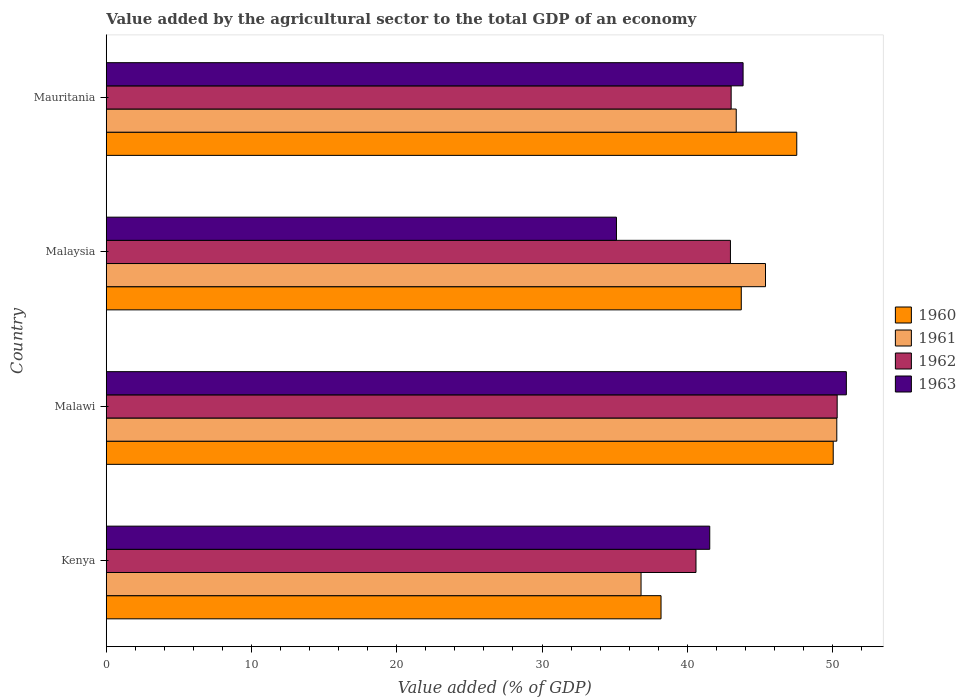How many different coloured bars are there?
Provide a succinct answer. 4. Are the number of bars per tick equal to the number of legend labels?
Your response must be concise. Yes. How many bars are there on the 1st tick from the bottom?
Offer a very short reply. 4. What is the label of the 2nd group of bars from the top?
Provide a succinct answer. Malaysia. What is the value added by the agricultural sector to the total GDP in 1960 in Mauritania?
Provide a succinct answer. 47.53. Across all countries, what is the maximum value added by the agricultural sector to the total GDP in 1963?
Ensure brevity in your answer.  50.95. Across all countries, what is the minimum value added by the agricultural sector to the total GDP in 1962?
Provide a short and direct response. 40.6. In which country was the value added by the agricultural sector to the total GDP in 1961 maximum?
Provide a succinct answer. Malawi. In which country was the value added by the agricultural sector to the total GDP in 1961 minimum?
Your answer should be very brief. Kenya. What is the total value added by the agricultural sector to the total GDP in 1961 in the graph?
Provide a short and direct response. 175.86. What is the difference between the value added by the agricultural sector to the total GDP in 1960 in Kenya and that in Malawi?
Ensure brevity in your answer.  -11.85. What is the difference between the value added by the agricultural sector to the total GDP in 1961 in Kenya and the value added by the agricultural sector to the total GDP in 1960 in Malawi?
Offer a terse response. -13.23. What is the average value added by the agricultural sector to the total GDP in 1962 per country?
Provide a short and direct response. 44.23. What is the difference between the value added by the agricultural sector to the total GDP in 1960 and value added by the agricultural sector to the total GDP in 1963 in Malawi?
Ensure brevity in your answer.  -0.9. What is the ratio of the value added by the agricultural sector to the total GDP in 1960 in Kenya to that in Mauritania?
Your answer should be compact. 0.8. What is the difference between the highest and the second highest value added by the agricultural sector to the total GDP in 1961?
Ensure brevity in your answer.  4.91. What is the difference between the highest and the lowest value added by the agricultural sector to the total GDP in 1960?
Provide a succinct answer. 11.85. In how many countries, is the value added by the agricultural sector to the total GDP in 1961 greater than the average value added by the agricultural sector to the total GDP in 1961 taken over all countries?
Offer a very short reply. 2. Is the sum of the value added by the agricultural sector to the total GDP in 1963 in Kenya and Malawi greater than the maximum value added by the agricultural sector to the total GDP in 1960 across all countries?
Make the answer very short. Yes. What does the 1st bar from the bottom in Malawi represents?
Your answer should be compact. 1960. How many countries are there in the graph?
Make the answer very short. 4. Are the values on the major ticks of X-axis written in scientific E-notation?
Give a very brief answer. No. Does the graph contain any zero values?
Offer a very short reply. No. Where does the legend appear in the graph?
Your answer should be compact. Center right. How many legend labels are there?
Offer a terse response. 4. How are the legend labels stacked?
Make the answer very short. Vertical. What is the title of the graph?
Make the answer very short. Value added by the agricultural sector to the total GDP of an economy. What is the label or title of the X-axis?
Ensure brevity in your answer.  Value added (% of GDP). What is the label or title of the Y-axis?
Your answer should be very brief. Country. What is the Value added (% of GDP) in 1960 in Kenya?
Provide a short and direct response. 38.19. What is the Value added (% of GDP) in 1961 in Kenya?
Your answer should be compact. 36.82. What is the Value added (% of GDP) of 1962 in Kenya?
Your answer should be compact. 40.6. What is the Value added (% of GDP) of 1963 in Kenya?
Offer a terse response. 41.54. What is the Value added (% of GDP) of 1960 in Malawi?
Your response must be concise. 50.04. What is the Value added (% of GDP) in 1961 in Malawi?
Keep it short and to the point. 50.29. What is the Value added (% of GDP) in 1962 in Malawi?
Keep it short and to the point. 50.32. What is the Value added (% of GDP) of 1963 in Malawi?
Your response must be concise. 50.95. What is the Value added (% of GDP) in 1960 in Malaysia?
Your answer should be very brief. 43.72. What is the Value added (% of GDP) of 1961 in Malaysia?
Your answer should be very brief. 45.38. What is the Value added (% of GDP) in 1962 in Malaysia?
Your response must be concise. 42.97. What is the Value added (% of GDP) of 1963 in Malaysia?
Ensure brevity in your answer.  35.12. What is the Value added (% of GDP) in 1960 in Mauritania?
Offer a terse response. 47.53. What is the Value added (% of GDP) in 1961 in Mauritania?
Your answer should be very brief. 43.37. What is the Value added (% of GDP) of 1962 in Mauritania?
Give a very brief answer. 43.02. What is the Value added (% of GDP) of 1963 in Mauritania?
Provide a succinct answer. 43.84. Across all countries, what is the maximum Value added (% of GDP) in 1960?
Offer a terse response. 50.04. Across all countries, what is the maximum Value added (% of GDP) in 1961?
Make the answer very short. 50.29. Across all countries, what is the maximum Value added (% of GDP) of 1962?
Give a very brief answer. 50.32. Across all countries, what is the maximum Value added (% of GDP) in 1963?
Offer a very short reply. 50.95. Across all countries, what is the minimum Value added (% of GDP) of 1960?
Your answer should be compact. 38.19. Across all countries, what is the minimum Value added (% of GDP) in 1961?
Keep it short and to the point. 36.82. Across all countries, what is the minimum Value added (% of GDP) of 1962?
Make the answer very short. 40.6. Across all countries, what is the minimum Value added (% of GDP) of 1963?
Provide a short and direct response. 35.12. What is the total Value added (% of GDP) in 1960 in the graph?
Your response must be concise. 179.49. What is the total Value added (% of GDP) in 1961 in the graph?
Make the answer very short. 175.86. What is the total Value added (% of GDP) in 1962 in the graph?
Give a very brief answer. 176.9. What is the total Value added (% of GDP) in 1963 in the graph?
Keep it short and to the point. 171.46. What is the difference between the Value added (% of GDP) in 1960 in Kenya and that in Malawi?
Ensure brevity in your answer.  -11.85. What is the difference between the Value added (% of GDP) of 1961 in Kenya and that in Malawi?
Offer a very short reply. -13.47. What is the difference between the Value added (% of GDP) in 1962 in Kenya and that in Malawi?
Keep it short and to the point. -9.72. What is the difference between the Value added (% of GDP) in 1963 in Kenya and that in Malawi?
Provide a succinct answer. -9.4. What is the difference between the Value added (% of GDP) in 1960 in Kenya and that in Malaysia?
Keep it short and to the point. -5.52. What is the difference between the Value added (% of GDP) of 1961 in Kenya and that in Malaysia?
Your response must be concise. -8.57. What is the difference between the Value added (% of GDP) in 1962 in Kenya and that in Malaysia?
Your response must be concise. -2.37. What is the difference between the Value added (% of GDP) of 1963 in Kenya and that in Malaysia?
Make the answer very short. 6.42. What is the difference between the Value added (% of GDP) in 1960 in Kenya and that in Mauritania?
Make the answer very short. -9.34. What is the difference between the Value added (% of GDP) in 1961 in Kenya and that in Mauritania?
Provide a succinct answer. -6.55. What is the difference between the Value added (% of GDP) of 1962 in Kenya and that in Mauritania?
Your response must be concise. -2.42. What is the difference between the Value added (% of GDP) in 1963 in Kenya and that in Mauritania?
Make the answer very short. -2.3. What is the difference between the Value added (% of GDP) in 1960 in Malawi and that in Malaysia?
Offer a very short reply. 6.33. What is the difference between the Value added (% of GDP) of 1961 in Malawi and that in Malaysia?
Your answer should be very brief. 4.91. What is the difference between the Value added (% of GDP) in 1962 in Malawi and that in Malaysia?
Ensure brevity in your answer.  7.35. What is the difference between the Value added (% of GDP) in 1963 in Malawi and that in Malaysia?
Your response must be concise. 15.83. What is the difference between the Value added (% of GDP) of 1960 in Malawi and that in Mauritania?
Ensure brevity in your answer.  2.51. What is the difference between the Value added (% of GDP) in 1961 in Malawi and that in Mauritania?
Ensure brevity in your answer.  6.92. What is the difference between the Value added (% of GDP) in 1962 in Malawi and that in Mauritania?
Give a very brief answer. 7.3. What is the difference between the Value added (% of GDP) of 1963 in Malawi and that in Mauritania?
Your answer should be very brief. 7.11. What is the difference between the Value added (% of GDP) in 1960 in Malaysia and that in Mauritania?
Ensure brevity in your answer.  -3.82. What is the difference between the Value added (% of GDP) of 1961 in Malaysia and that in Mauritania?
Keep it short and to the point. 2.01. What is the difference between the Value added (% of GDP) in 1962 in Malaysia and that in Mauritania?
Your response must be concise. -0.05. What is the difference between the Value added (% of GDP) of 1963 in Malaysia and that in Mauritania?
Offer a terse response. -8.72. What is the difference between the Value added (% of GDP) of 1960 in Kenya and the Value added (% of GDP) of 1961 in Malawi?
Provide a succinct answer. -12.1. What is the difference between the Value added (% of GDP) of 1960 in Kenya and the Value added (% of GDP) of 1962 in Malawi?
Offer a terse response. -12.12. What is the difference between the Value added (% of GDP) in 1960 in Kenya and the Value added (% of GDP) in 1963 in Malawi?
Your response must be concise. -12.76. What is the difference between the Value added (% of GDP) in 1961 in Kenya and the Value added (% of GDP) in 1962 in Malawi?
Your response must be concise. -13.5. What is the difference between the Value added (% of GDP) in 1961 in Kenya and the Value added (% of GDP) in 1963 in Malawi?
Provide a succinct answer. -14.13. What is the difference between the Value added (% of GDP) of 1962 in Kenya and the Value added (% of GDP) of 1963 in Malawi?
Ensure brevity in your answer.  -10.35. What is the difference between the Value added (% of GDP) in 1960 in Kenya and the Value added (% of GDP) in 1961 in Malaysia?
Give a very brief answer. -7.19. What is the difference between the Value added (% of GDP) in 1960 in Kenya and the Value added (% of GDP) in 1962 in Malaysia?
Give a very brief answer. -4.78. What is the difference between the Value added (% of GDP) in 1960 in Kenya and the Value added (% of GDP) in 1963 in Malaysia?
Your answer should be compact. 3.07. What is the difference between the Value added (% of GDP) in 1961 in Kenya and the Value added (% of GDP) in 1962 in Malaysia?
Ensure brevity in your answer.  -6.15. What is the difference between the Value added (% of GDP) in 1961 in Kenya and the Value added (% of GDP) in 1963 in Malaysia?
Keep it short and to the point. 1.69. What is the difference between the Value added (% of GDP) in 1962 in Kenya and the Value added (% of GDP) in 1963 in Malaysia?
Your response must be concise. 5.47. What is the difference between the Value added (% of GDP) in 1960 in Kenya and the Value added (% of GDP) in 1961 in Mauritania?
Your answer should be very brief. -5.18. What is the difference between the Value added (% of GDP) in 1960 in Kenya and the Value added (% of GDP) in 1962 in Mauritania?
Ensure brevity in your answer.  -4.83. What is the difference between the Value added (% of GDP) in 1960 in Kenya and the Value added (% of GDP) in 1963 in Mauritania?
Your answer should be compact. -5.65. What is the difference between the Value added (% of GDP) in 1961 in Kenya and the Value added (% of GDP) in 1962 in Mauritania?
Offer a very short reply. -6.2. What is the difference between the Value added (% of GDP) of 1961 in Kenya and the Value added (% of GDP) of 1963 in Mauritania?
Offer a very short reply. -7.02. What is the difference between the Value added (% of GDP) in 1962 in Kenya and the Value added (% of GDP) in 1963 in Mauritania?
Keep it short and to the point. -3.24. What is the difference between the Value added (% of GDP) in 1960 in Malawi and the Value added (% of GDP) in 1961 in Malaysia?
Your response must be concise. 4.66. What is the difference between the Value added (% of GDP) in 1960 in Malawi and the Value added (% of GDP) in 1962 in Malaysia?
Offer a terse response. 7.08. What is the difference between the Value added (% of GDP) of 1960 in Malawi and the Value added (% of GDP) of 1963 in Malaysia?
Your answer should be very brief. 14.92. What is the difference between the Value added (% of GDP) in 1961 in Malawi and the Value added (% of GDP) in 1962 in Malaysia?
Ensure brevity in your answer.  7.32. What is the difference between the Value added (% of GDP) of 1961 in Malawi and the Value added (% of GDP) of 1963 in Malaysia?
Offer a very short reply. 15.17. What is the difference between the Value added (% of GDP) in 1962 in Malawi and the Value added (% of GDP) in 1963 in Malaysia?
Offer a very short reply. 15.19. What is the difference between the Value added (% of GDP) in 1960 in Malawi and the Value added (% of GDP) in 1961 in Mauritania?
Make the answer very short. 6.68. What is the difference between the Value added (% of GDP) in 1960 in Malawi and the Value added (% of GDP) in 1962 in Mauritania?
Keep it short and to the point. 7.03. What is the difference between the Value added (% of GDP) in 1960 in Malawi and the Value added (% of GDP) in 1963 in Mauritania?
Offer a terse response. 6.2. What is the difference between the Value added (% of GDP) in 1961 in Malawi and the Value added (% of GDP) in 1962 in Mauritania?
Provide a succinct answer. 7.27. What is the difference between the Value added (% of GDP) of 1961 in Malawi and the Value added (% of GDP) of 1963 in Mauritania?
Your answer should be very brief. 6.45. What is the difference between the Value added (% of GDP) in 1962 in Malawi and the Value added (% of GDP) in 1963 in Mauritania?
Your answer should be compact. 6.48. What is the difference between the Value added (% of GDP) of 1960 in Malaysia and the Value added (% of GDP) of 1961 in Mauritania?
Your answer should be very brief. 0.35. What is the difference between the Value added (% of GDP) of 1960 in Malaysia and the Value added (% of GDP) of 1962 in Mauritania?
Give a very brief answer. 0.7. What is the difference between the Value added (% of GDP) in 1960 in Malaysia and the Value added (% of GDP) in 1963 in Mauritania?
Your response must be concise. -0.12. What is the difference between the Value added (% of GDP) of 1961 in Malaysia and the Value added (% of GDP) of 1962 in Mauritania?
Give a very brief answer. 2.36. What is the difference between the Value added (% of GDP) of 1961 in Malaysia and the Value added (% of GDP) of 1963 in Mauritania?
Keep it short and to the point. 1.54. What is the difference between the Value added (% of GDP) in 1962 in Malaysia and the Value added (% of GDP) in 1963 in Mauritania?
Your answer should be very brief. -0.87. What is the average Value added (% of GDP) in 1960 per country?
Make the answer very short. 44.87. What is the average Value added (% of GDP) in 1961 per country?
Your answer should be very brief. 43.96. What is the average Value added (% of GDP) of 1962 per country?
Provide a succinct answer. 44.23. What is the average Value added (% of GDP) of 1963 per country?
Provide a succinct answer. 42.86. What is the difference between the Value added (% of GDP) in 1960 and Value added (% of GDP) in 1961 in Kenya?
Provide a short and direct response. 1.38. What is the difference between the Value added (% of GDP) of 1960 and Value added (% of GDP) of 1962 in Kenya?
Ensure brevity in your answer.  -2.41. What is the difference between the Value added (% of GDP) of 1960 and Value added (% of GDP) of 1963 in Kenya?
Give a very brief answer. -3.35. What is the difference between the Value added (% of GDP) in 1961 and Value added (% of GDP) in 1962 in Kenya?
Keep it short and to the point. -3.78. What is the difference between the Value added (% of GDP) of 1961 and Value added (% of GDP) of 1963 in Kenya?
Your answer should be very brief. -4.73. What is the difference between the Value added (% of GDP) of 1962 and Value added (% of GDP) of 1963 in Kenya?
Provide a succinct answer. -0.95. What is the difference between the Value added (% of GDP) in 1960 and Value added (% of GDP) in 1961 in Malawi?
Ensure brevity in your answer.  -0.25. What is the difference between the Value added (% of GDP) of 1960 and Value added (% of GDP) of 1962 in Malawi?
Provide a short and direct response. -0.27. What is the difference between the Value added (% of GDP) in 1960 and Value added (% of GDP) in 1963 in Malawi?
Provide a succinct answer. -0.9. What is the difference between the Value added (% of GDP) of 1961 and Value added (% of GDP) of 1962 in Malawi?
Offer a very short reply. -0.03. What is the difference between the Value added (% of GDP) of 1961 and Value added (% of GDP) of 1963 in Malawi?
Make the answer very short. -0.66. What is the difference between the Value added (% of GDP) of 1962 and Value added (% of GDP) of 1963 in Malawi?
Offer a terse response. -0.63. What is the difference between the Value added (% of GDP) of 1960 and Value added (% of GDP) of 1961 in Malaysia?
Your answer should be compact. -1.67. What is the difference between the Value added (% of GDP) in 1960 and Value added (% of GDP) in 1962 in Malaysia?
Make the answer very short. 0.75. What is the difference between the Value added (% of GDP) of 1960 and Value added (% of GDP) of 1963 in Malaysia?
Your response must be concise. 8.59. What is the difference between the Value added (% of GDP) in 1961 and Value added (% of GDP) in 1962 in Malaysia?
Ensure brevity in your answer.  2.41. What is the difference between the Value added (% of GDP) of 1961 and Value added (% of GDP) of 1963 in Malaysia?
Ensure brevity in your answer.  10.26. What is the difference between the Value added (% of GDP) in 1962 and Value added (% of GDP) in 1963 in Malaysia?
Make the answer very short. 7.84. What is the difference between the Value added (% of GDP) of 1960 and Value added (% of GDP) of 1961 in Mauritania?
Provide a short and direct response. 4.17. What is the difference between the Value added (% of GDP) of 1960 and Value added (% of GDP) of 1962 in Mauritania?
Provide a short and direct response. 4.52. What is the difference between the Value added (% of GDP) of 1960 and Value added (% of GDP) of 1963 in Mauritania?
Offer a terse response. 3.69. What is the difference between the Value added (% of GDP) of 1961 and Value added (% of GDP) of 1962 in Mauritania?
Provide a succinct answer. 0.35. What is the difference between the Value added (% of GDP) of 1961 and Value added (% of GDP) of 1963 in Mauritania?
Offer a very short reply. -0.47. What is the difference between the Value added (% of GDP) of 1962 and Value added (% of GDP) of 1963 in Mauritania?
Keep it short and to the point. -0.82. What is the ratio of the Value added (% of GDP) of 1960 in Kenya to that in Malawi?
Your response must be concise. 0.76. What is the ratio of the Value added (% of GDP) in 1961 in Kenya to that in Malawi?
Offer a very short reply. 0.73. What is the ratio of the Value added (% of GDP) of 1962 in Kenya to that in Malawi?
Your answer should be very brief. 0.81. What is the ratio of the Value added (% of GDP) in 1963 in Kenya to that in Malawi?
Make the answer very short. 0.82. What is the ratio of the Value added (% of GDP) in 1960 in Kenya to that in Malaysia?
Offer a very short reply. 0.87. What is the ratio of the Value added (% of GDP) of 1961 in Kenya to that in Malaysia?
Your answer should be very brief. 0.81. What is the ratio of the Value added (% of GDP) in 1962 in Kenya to that in Malaysia?
Your response must be concise. 0.94. What is the ratio of the Value added (% of GDP) in 1963 in Kenya to that in Malaysia?
Offer a very short reply. 1.18. What is the ratio of the Value added (% of GDP) in 1960 in Kenya to that in Mauritania?
Your answer should be compact. 0.8. What is the ratio of the Value added (% of GDP) in 1961 in Kenya to that in Mauritania?
Provide a short and direct response. 0.85. What is the ratio of the Value added (% of GDP) of 1962 in Kenya to that in Mauritania?
Ensure brevity in your answer.  0.94. What is the ratio of the Value added (% of GDP) in 1963 in Kenya to that in Mauritania?
Give a very brief answer. 0.95. What is the ratio of the Value added (% of GDP) in 1960 in Malawi to that in Malaysia?
Offer a terse response. 1.14. What is the ratio of the Value added (% of GDP) in 1961 in Malawi to that in Malaysia?
Your answer should be very brief. 1.11. What is the ratio of the Value added (% of GDP) of 1962 in Malawi to that in Malaysia?
Provide a short and direct response. 1.17. What is the ratio of the Value added (% of GDP) in 1963 in Malawi to that in Malaysia?
Make the answer very short. 1.45. What is the ratio of the Value added (% of GDP) of 1960 in Malawi to that in Mauritania?
Your answer should be compact. 1.05. What is the ratio of the Value added (% of GDP) in 1961 in Malawi to that in Mauritania?
Give a very brief answer. 1.16. What is the ratio of the Value added (% of GDP) in 1962 in Malawi to that in Mauritania?
Your answer should be very brief. 1.17. What is the ratio of the Value added (% of GDP) of 1963 in Malawi to that in Mauritania?
Offer a very short reply. 1.16. What is the ratio of the Value added (% of GDP) in 1960 in Malaysia to that in Mauritania?
Provide a succinct answer. 0.92. What is the ratio of the Value added (% of GDP) of 1961 in Malaysia to that in Mauritania?
Give a very brief answer. 1.05. What is the ratio of the Value added (% of GDP) in 1962 in Malaysia to that in Mauritania?
Your answer should be compact. 1. What is the ratio of the Value added (% of GDP) in 1963 in Malaysia to that in Mauritania?
Provide a short and direct response. 0.8. What is the difference between the highest and the second highest Value added (% of GDP) in 1960?
Provide a short and direct response. 2.51. What is the difference between the highest and the second highest Value added (% of GDP) of 1961?
Offer a terse response. 4.91. What is the difference between the highest and the second highest Value added (% of GDP) in 1962?
Offer a very short reply. 7.3. What is the difference between the highest and the second highest Value added (% of GDP) in 1963?
Offer a terse response. 7.11. What is the difference between the highest and the lowest Value added (% of GDP) of 1960?
Provide a succinct answer. 11.85. What is the difference between the highest and the lowest Value added (% of GDP) of 1961?
Make the answer very short. 13.47. What is the difference between the highest and the lowest Value added (% of GDP) in 1962?
Keep it short and to the point. 9.72. What is the difference between the highest and the lowest Value added (% of GDP) of 1963?
Provide a succinct answer. 15.83. 